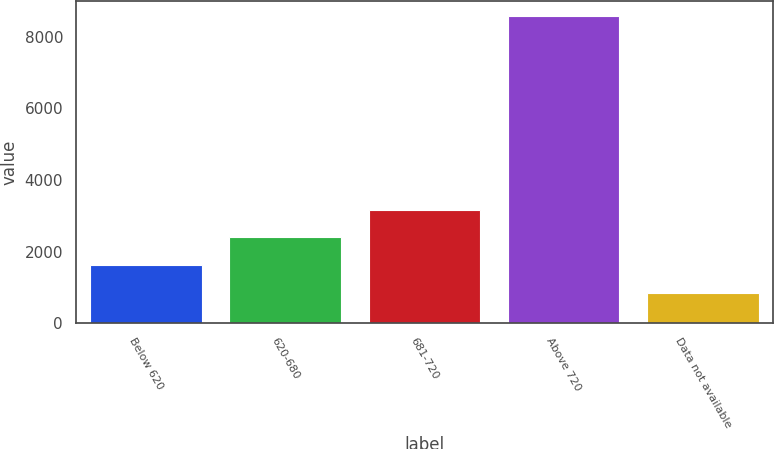Convert chart. <chart><loc_0><loc_0><loc_500><loc_500><bar_chart><fcel>Below 620<fcel>620-680<fcel>681-720<fcel>Above 720<fcel>Data not available<nl><fcel>1628<fcel>2400<fcel>3172<fcel>8576<fcel>856<nl></chart> 